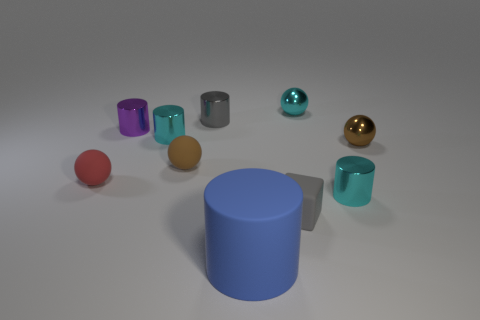Is there any other thing that is the same shape as the small gray matte thing?
Provide a succinct answer. No. What number of rubber things are either tiny green blocks or balls?
Your response must be concise. 2. What is the shape of the small object that is the same color as the matte block?
Ensure brevity in your answer.  Cylinder. Do the small cylinder that is in front of the red rubber ball and the small block have the same color?
Provide a succinct answer. No. What is the shape of the purple metal thing behind the brown matte sphere that is to the right of the small red thing?
Keep it short and to the point. Cylinder. What number of things are shiny things behind the red matte ball or small cylinders that are left of the tiny gray cylinder?
Provide a short and direct response. 5. The blue thing that is made of the same material as the cube is what shape?
Offer a terse response. Cylinder. Is there any other thing that has the same color as the small cube?
Offer a very short reply. Yes. There is a tiny red object that is the same shape as the tiny brown shiny object; what is it made of?
Offer a terse response. Rubber. How many other things are the same size as the blue matte object?
Offer a terse response. 0. 